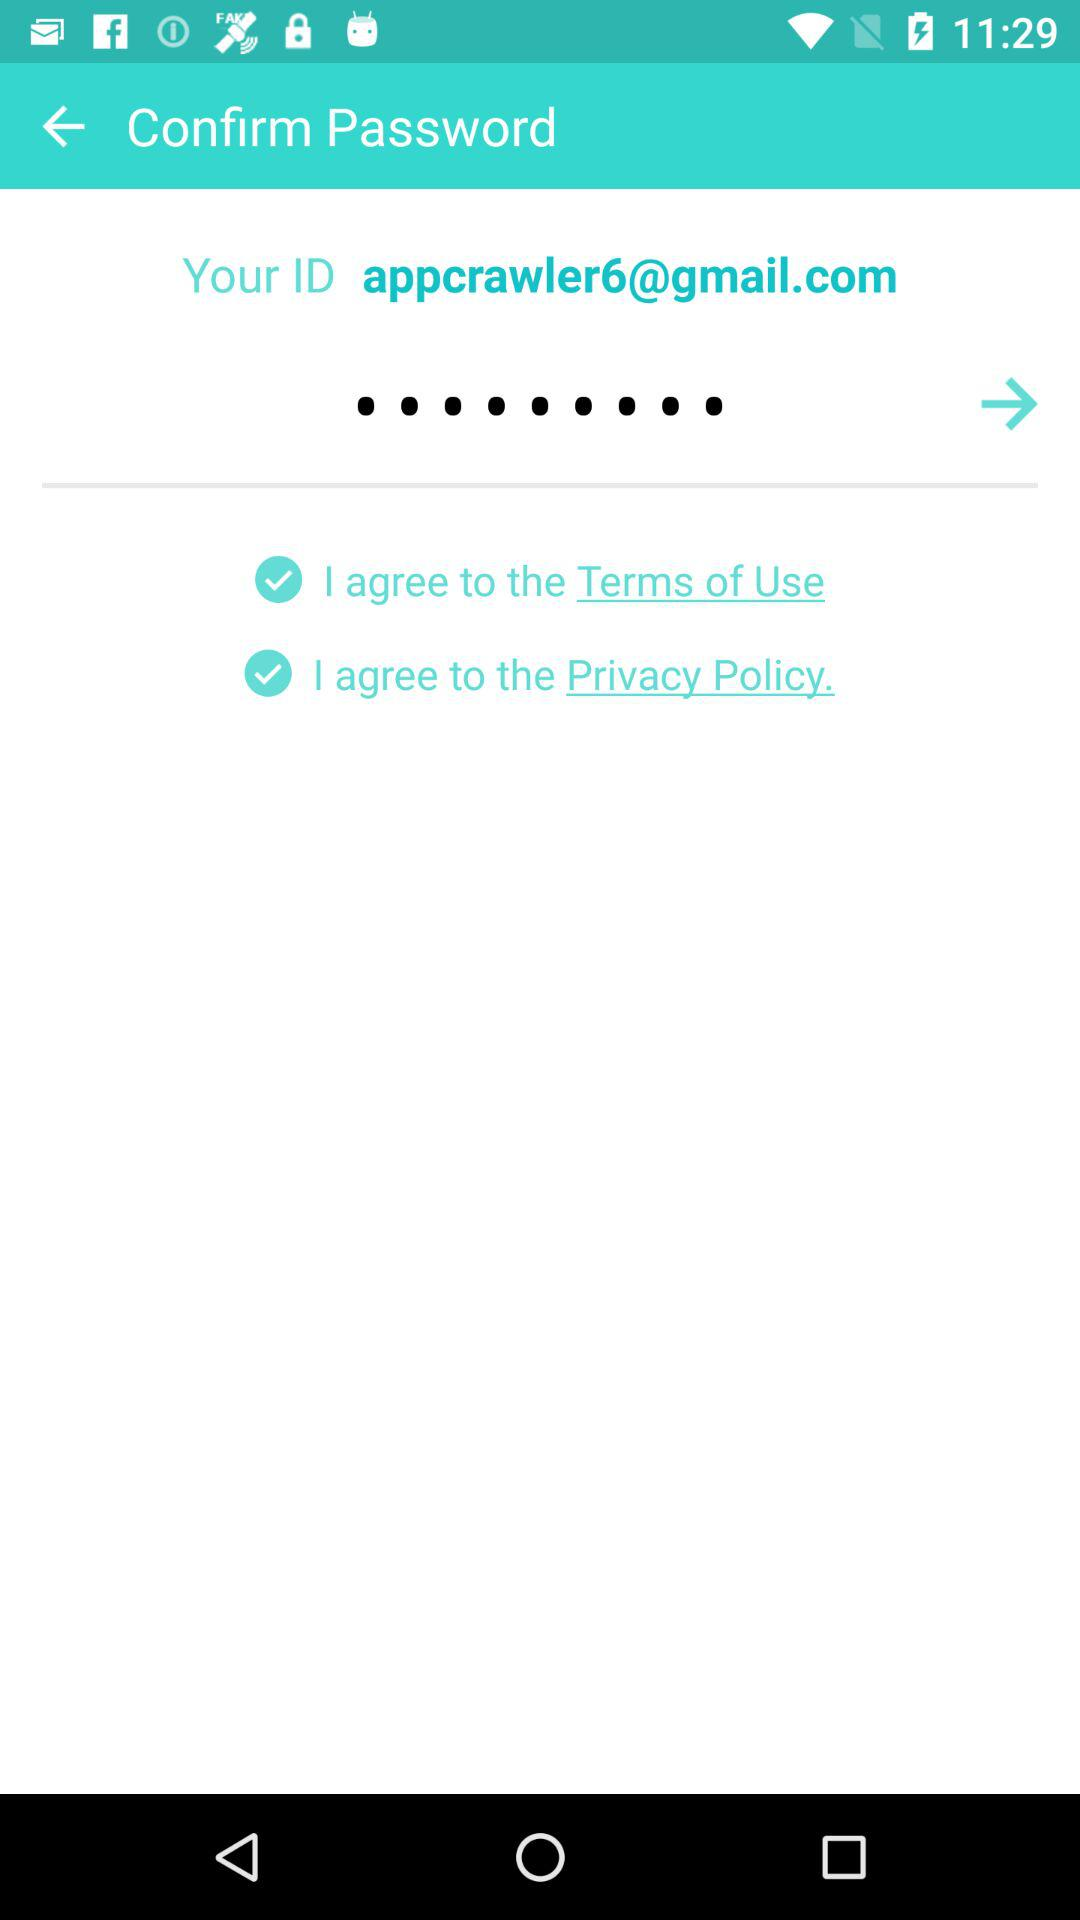How many check boxes are there on the screen?
Answer the question using a single word or phrase. 2 